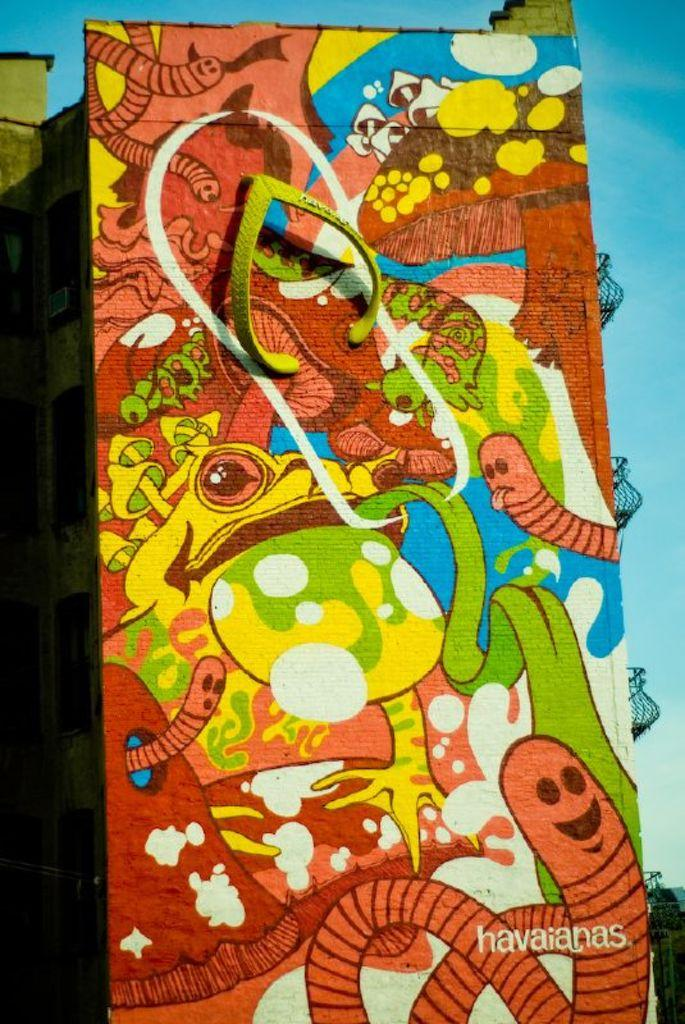<image>
Render a clear and concise summary of the photo. A piece of art is signed as being by havaianas. 